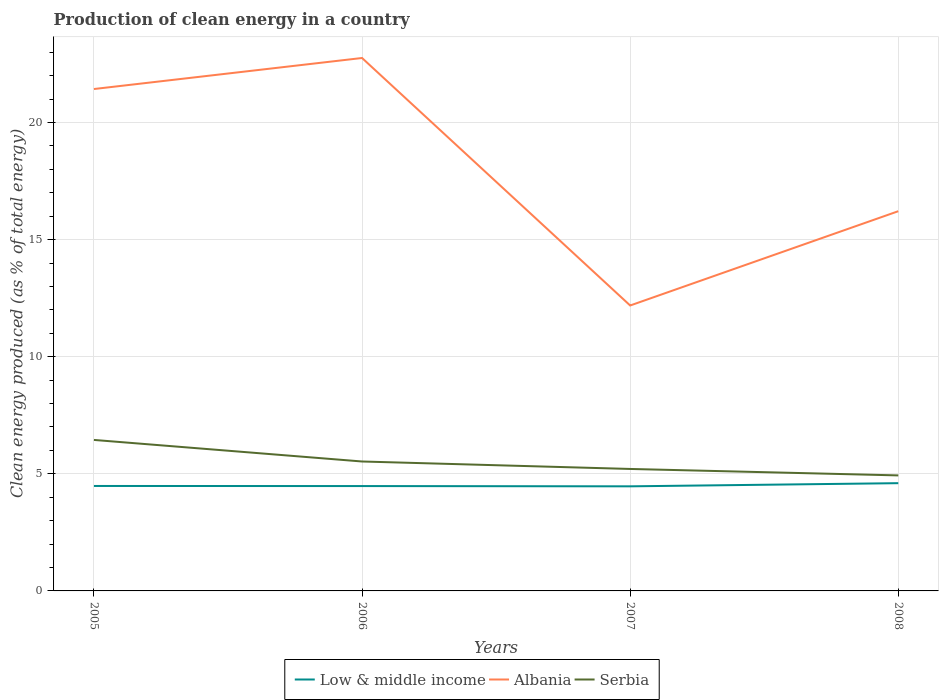Is the number of lines equal to the number of legend labels?
Make the answer very short. Yes. Across all years, what is the maximum percentage of clean energy produced in Serbia?
Make the answer very short. 4.93. In which year was the percentage of clean energy produced in Serbia maximum?
Offer a terse response. 2008. What is the total percentage of clean energy produced in Serbia in the graph?
Ensure brevity in your answer.  0.59. What is the difference between the highest and the second highest percentage of clean energy produced in Low & middle income?
Ensure brevity in your answer.  0.13. Is the percentage of clean energy produced in Albania strictly greater than the percentage of clean energy produced in Low & middle income over the years?
Offer a terse response. No. How many lines are there?
Your answer should be very brief. 3. What is the difference between two consecutive major ticks on the Y-axis?
Provide a short and direct response. 5. Does the graph contain any zero values?
Offer a very short reply. No. Does the graph contain grids?
Make the answer very short. Yes. Where does the legend appear in the graph?
Give a very brief answer. Bottom center. How many legend labels are there?
Your response must be concise. 3. What is the title of the graph?
Offer a very short reply. Production of clean energy in a country. What is the label or title of the Y-axis?
Ensure brevity in your answer.  Clean energy produced (as % of total energy). What is the Clean energy produced (as % of total energy) of Low & middle income in 2005?
Provide a succinct answer. 4.48. What is the Clean energy produced (as % of total energy) of Albania in 2005?
Provide a short and direct response. 21.43. What is the Clean energy produced (as % of total energy) in Serbia in 2005?
Your answer should be very brief. 6.45. What is the Clean energy produced (as % of total energy) of Low & middle income in 2006?
Offer a very short reply. 4.48. What is the Clean energy produced (as % of total energy) of Albania in 2006?
Provide a succinct answer. 22.75. What is the Clean energy produced (as % of total energy) in Serbia in 2006?
Ensure brevity in your answer.  5.53. What is the Clean energy produced (as % of total energy) of Low & middle income in 2007?
Ensure brevity in your answer.  4.47. What is the Clean energy produced (as % of total energy) in Albania in 2007?
Make the answer very short. 12.19. What is the Clean energy produced (as % of total energy) in Serbia in 2007?
Give a very brief answer. 5.21. What is the Clean energy produced (as % of total energy) of Low & middle income in 2008?
Offer a very short reply. 4.6. What is the Clean energy produced (as % of total energy) in Albania in 2008?
Your response must be concise. 16.21. What is the Clean energy produced (as % of total energy) in Serbia in 2008?
Your answer should be very brief. 4.93. Across all years, what is the maximum Clean energy produced (as % of total energy) of Low & middle income?
Your answer should be very brief. 4.6. Across all years, what is the maximum Clean energy produced (as % of total energy) of Albania?
Provide a succinct answer. 22.75. Across all years, what is the maximum Clean energy produced (as % of total energy) in Serbia?
Your answer should be very brief. 6.45. Across all years, what is the minimum Clean energy produced (as % of total energy) of Low & middle income?
Ensure brevity in your answer.  4.47. Across all years, what is the minimum Clean energy produced (as % of total energy) in Albania?
Give a very brief answer. 12.19. Across all years, what is the minimum Clean energy produced (as % of total energy) of Serbia?
Give a very brief answer. 4.93. What is the total Clean energy produced (as % of total energy) in Low & middle income in the graph?
Provide a short and direct response. 18.02. What is the total Clean energy produced (as % of total energy) in Albania in the graph?
Your answer should be compact. 72.58. What is the total Clean energy produced (as % of total energy) in Serbia in the graph?
Provide a short and direct response. 22.11. What is the difference between the Clean energy produced (as % of total energy) of Low & middle income in 2005 and that in 2006?
Offer a terse response. 0. What is the difference between the Clean energy produced (as % of total energy) of Albania in 2005 and that in 2006?
Give a very brief answer. -1.32. What is the difference between the Clean energy produced (as % of total energy) in Serbia in 2005 and that in 2006?
Offer a terse response. 0.92. What is the difference between the Clean energy produced (as % of total energy) of Low & middle income in 2005 and that in 2007?
Provide a short and direct response. 0.02. What is the difference between the Clean energy produced (as % of total energy) in Albania in 2005 and that in 2007?
Your answer should be compact. 9.24. What is the difference between the Clean energy produced (as % of total energy) in Serbia in 2005 and that in 2007?
Keep it short and to the point. 1.24. What is the difference between the Clean energy produced (as % of total energy) in Low & middle income in 2005 and that in 2008?
Your response must be concise. -0.12. What is the difference between the Clean energy produced (as % of total energy) of Albania in 2005 and that in 2008?
Offer a terse response. 5.22. What is the difference between the Clean energy produced (as % of total energy) in Serbia in 2005 and that in 2008?
Your answer should be compact. 1.51. What is the difference between the Clean energy produced (as % of total energy) in Low & middle income in 2006 and that in 2007?
Offer a terse response. 0.01. What is the difference between the Clean energy produced (as % of total energy) of Albania in 2006 and that in 2007?
Give a very brief answer. 10.57. What is the difference between the Clean energy produced (as % of total energy) of Serbia in 2006 and that in 2007?
Your answer should be very brief. 0.32. What is the difference between the Clean energy produced (as % of total energy) of Low & middle income in 2006 and that in 2008?
Keep it short and to the point. -0.12. What is the difference between the Clean energy produced (as % of total energy) in Albania in 2006 and that in 2008?
Your answer should be compact. 6.54. What is the difference between the Clean energy produced (as % of total energy) of Serbia in 2006 and that in 2008?
Provide a short and direct response. 0.59. What is the difference between the Clean energy produced (as % of total energy) in Low & middle income in 2007 and that in 2008?
Offer a very short reply. -0.13. What is the difference between the Clean energy produced (as % of total energy) of Albania in 2007 and that in 2008?
Keep it short and to the point. -4.03. What is the difference between the Clean energy produced (as % of total energy) of Serbia in 2007 and that in 2008?
Your answer should be compact. 0.28. What is the difference between the Clean energy produced (as % of total energy) in Low & middle income in 2005 and the Clean energy produced (as % of total energy) in Albania in 2006?
Your response must be concise. -18.27. What is the difference between the Clean energy produced (as % of total energy) of Low & middle income in 2005 and the Clean energy produced (as % of total energy) of Serbia in 2006?
Keep it short and to the point. -1.05. What is the difference between the Clean energy produced (as % of total energy) in Albania in 2005 and the Clean energy produced (as % of total energy) in Serbia in 2006?
Offer a terse response. 15.9. What is the difference between the Clean energy produced (as % of total energy) in Low & middle income in 2005 and the Clean energy produced (as % of total energy) in Albania in 2007?
Keep it short and to the point. -7.71. What is the difference between the Clean energy produced (as % of total energy) of Low & middle income in 2005 and the Clean energy produced (as % of total energy) of Serbia in 2007?
Make the answer very short. -0.73. What is the difference between the Clean energy produced (as % of total energy) of Albania in 2005 and the Clean energy produced (as % of total energy) of Serbia in 2007?
Your response must be concise. 16.22. What is the difference between the Clean energy produced (as % of total energy) of Low & middle income in 2005 and the Clean energy produced (as % of total energy) of Albania in 2008?
Keep it short and to the point. -11.73. What is the difference between the Clean energy produced (as % of total energy) in Low & middle income in 2005 and the Clean energy produced (as % of total energy) in Serbia in 2008?
Provide a succinct answer. -0.45. What is the difference between the Clean energy produced (as % of total energy) in Albania in 2005 and the Clean energy produced (as % of total energy) in Serbia in 2008?
Keep it short and to the point. 16.5. What is the difference between the Clean energy produced (as % of total energy) of Low & middle income in 2006 and the Clean energy produced (as % of total energy) of Albania in 2007?
Ensure brevity in your answer.  -7.71. What is the difference between the Clean energy produced (as % of total energy) of Low & middle income in 2006 and the Clean energy produced (as % of total energy) of Serbia in 2007?
Ensure brevity in your answer.  -0.73. What is the difference between the Clean energy produced (as % of total energy) in Albania in 2006 and the Clean energy produced (as % of total energy) in Serbia in 2007?
Give a very brief answer. 17.55. What is the difference between the Clean energy produced (as % of total energy) in Low & middle income in 2006 and the Clean energy produced (as % of total energy) in Albania in 2008?
Your response must be concise. -11.73. What is the difference between the Clean energy produced (as % of total energy) in Low & middle income in 2006 and the Clean energy produced (as % of total energy) in Serbia in 2008?
Keep it short and to the point. -0.46. What is the difference between the Clean energy produced (as % of total energy) of Albania in 2006 and the Clean energy produced (as % of total energy) of Serbia in 2008?
Provide a succinct answer. 17.82. What is the difference between the Clean energy produced (as % of total energy) in Low & middle income in 2007 and the Clean energy produced (as % of total energy) in Albania in 2008?
Your answer should be very brief. -11.75. What is the difference between the Clean energy produced (as % of total energy) of Low & middle income in 2007 and the Clean energy produced (as % of total energy) of Serbia in 2008?
Give a very brief answer. -0.47. What is the difference between the Clean energy produced (as % of total energy) in Albania in 2007 and the Clean energy produced (as % of total energy) in Serbia in 2008?
Provide a short and direct response. 7.25. What is the average Clean energy produced (as % of total energy) in Low & middle income per year?
Make the answer very short. 4.51. What is the average Clean energy produced (as % of total energy) in Albania per year?
Make the answer very short. 18.15. What is the average Clean energy produced (as % of total energy) in Serbia per year?
Your answer should be very brief. 5.53. In the year 2005, what is the difference between the Clean energy produced (as % of total energy) in Low & middle income and Clean energy produced (as % of total energy) in Albania?
Give a very brief answer. -16.95. In the year 2005, what is the difference between the Clean energy produced (as % of total energy) of Low & middle income and Clean energy produced (as % of total energy) of Serbia?
Your response must be concise. -1.97. In the year 2005, what is the difference between the Clean energy produced (as % of total energy) of Albania and Clean energy produced (as % of total energy) of Serbia?
Provide a short and direct response. 14.98. In the year 2006, what is the difference between the Clean energy produced (as % of total energy) in Low & middle income and Clean energy produced (as % of total energy) in Albania?
Your response must be concise. -18.28. In the year 2006, what is the difference between the Clean energy produced (as % of total energy) of Low & middle income and Clean energy produced (as % of total energy) of Serbia?
Ensure brevity in your answer.  -1.05. In the year 2006, what is the difference between the Clean energy produced (as % of total energy) of Albania and Clean energy produced (as % of total energy) of Serbia?
Make the answer very short. 17.23. In the year 2007, what is the difference between the Clean energy produced (as % of total energy) in Low & middle income and Clean energy produced (as % of total energy) in Albania?
Your answer should be very brief. -7.72. In the year 2007, what is the difference between the Clean energy produced (as % of total energy) in Low & middle income and Clean energy produced (as % of total energy) in Serbia?
Keep it short and to the point. -0.74. In the year 2007, what is the difference between the Clean energy produced (as % of total energy) in Albania and Clean energy produced (as % of total energy) in Serbia?
Keep it short and to the point. 6.98. In the year 2008, what is the difference between the Clean energy produced (as % of total energy) in Low & middle income and Clean energy produced (as % of total energy) in Albania?
Offer a very short reply. -11.61. In the year 2008, what is the difference between the Clean energy produced (as % of total energy) in Low & middle income and Clean energy produced (as % of total energy) in Serbia?
Make the answer very short. -0.33. In the year 2008, what is the difference between the Clean energy produced (as % of total energy) of Albania and Clean energy produced (as % of total energy) of Serbia?
Offer a very short reply. 11.28. What is the ratio of the Clean energy produced (as % of total energy) in Albania in 2005 to that in 2006?
Provide a short and direct response. 0.94. What is the ratio of the Clean energy produced (as % of total energy) in Serbia in 2005 to that in 2006?
Offer a very short reply. 1.17. What is the ratio of the Clean energy produced (as % of total energy) of Albania in 2005 to that in 2007?
Keep it short and to the point. 1.76. What is the ratio of the Clean energy produced (as % of total energy) in Serbia in 2005 to that in 2007?
Give a very brief answer. 1.24. What is the ratio of the Clean energy produced (as % of total energy) of Low & middle income in 2005 to that in 2008?
Offer a very short reply. 0.97. What is the ratio of the Clean energy produced (as % of total energy) of Albania in 2005 to that in 2008?
Offer a terse response. 1.32. What is the ratio of the Clean energy produced (as % of total energy) of Serbia in 2005 to that in 2008?
Your response must be concise. 1.31. What is the ratio of the Clean energy produced (as % of total energy) of Low & middle income in 2006 to that in 2007?
Give a very brief answer. 1. What is the ratio of the Clean energy produced (as % of total energy) of Albania in 2006 to that in 2007?
Provide a succinct answer. 1.87. What is the ratio of the Clean energy produced (as % of total energy) in Serbia in 2006 to that in 2007?
Offer a terse response. 1.06. What is the ratio of the Clean energy produced (as % of total energy) of Low & middle income in 2006 to that in 2008?
Ensure brevity in your answer.  0.97. What is the ratio of the Clean energy produced (as % of total energy) in Albania in 2006 to that in 2008?
Offer a terse response. 1.4. What is the ratio of the Clean energy produced (as % of total energy) of Serbia in 2006 to that in 2008?
Provide a short and direct response. 1.12. What is the ratio of the Clean energy produced (as % of total energy) in Low & middle income in 2007 to that in 2008?
Your answer should be very brief. 0.97. What is the ratio of the Clean energy produced (as % of total energy) of Albania in 2007 to that in 2008?
Offer a terse response. 0.75. What is the ratio of the Clean energy produced (as % of total energy) of Serbia in 2007 to that in 2008?
Keep it short and to the point. 1.06. What is the difference between the highest and the second highest Clean energy produced (as % of total energy) of Low & middle income?
Your answer should be compact. 0.12. What is the difference between the highest and the second highest Clean energy produced (as % of total energy) of Albania?
Offer a very short reply. 1.32. What is the difference between the highest and the second highest Clean energy produced (as % of total energy) of Serbia?
Offer a terse response. 0.92. What is the difference between the highest and the lowest Clean energy produced (as % of total energy) in Low & middle income?
Keep it short and to the point. 0.13. What is the difference between the highest and the lowest Clean energy produced (as % of total energy) of Albania?
Ensure brevity in your answer.  10.57. What is the difference between the highest and the lowest Clean energy produced (as % of total energy) of Serbia?
Your answer should be compact. 1.51. 